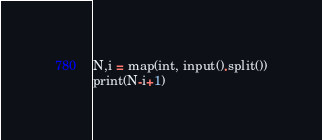<code> <loc_0><loc_0><loc_500><loc_500><_Python_>N,i = map(int, input().split())
print(N-i+1)</code> 